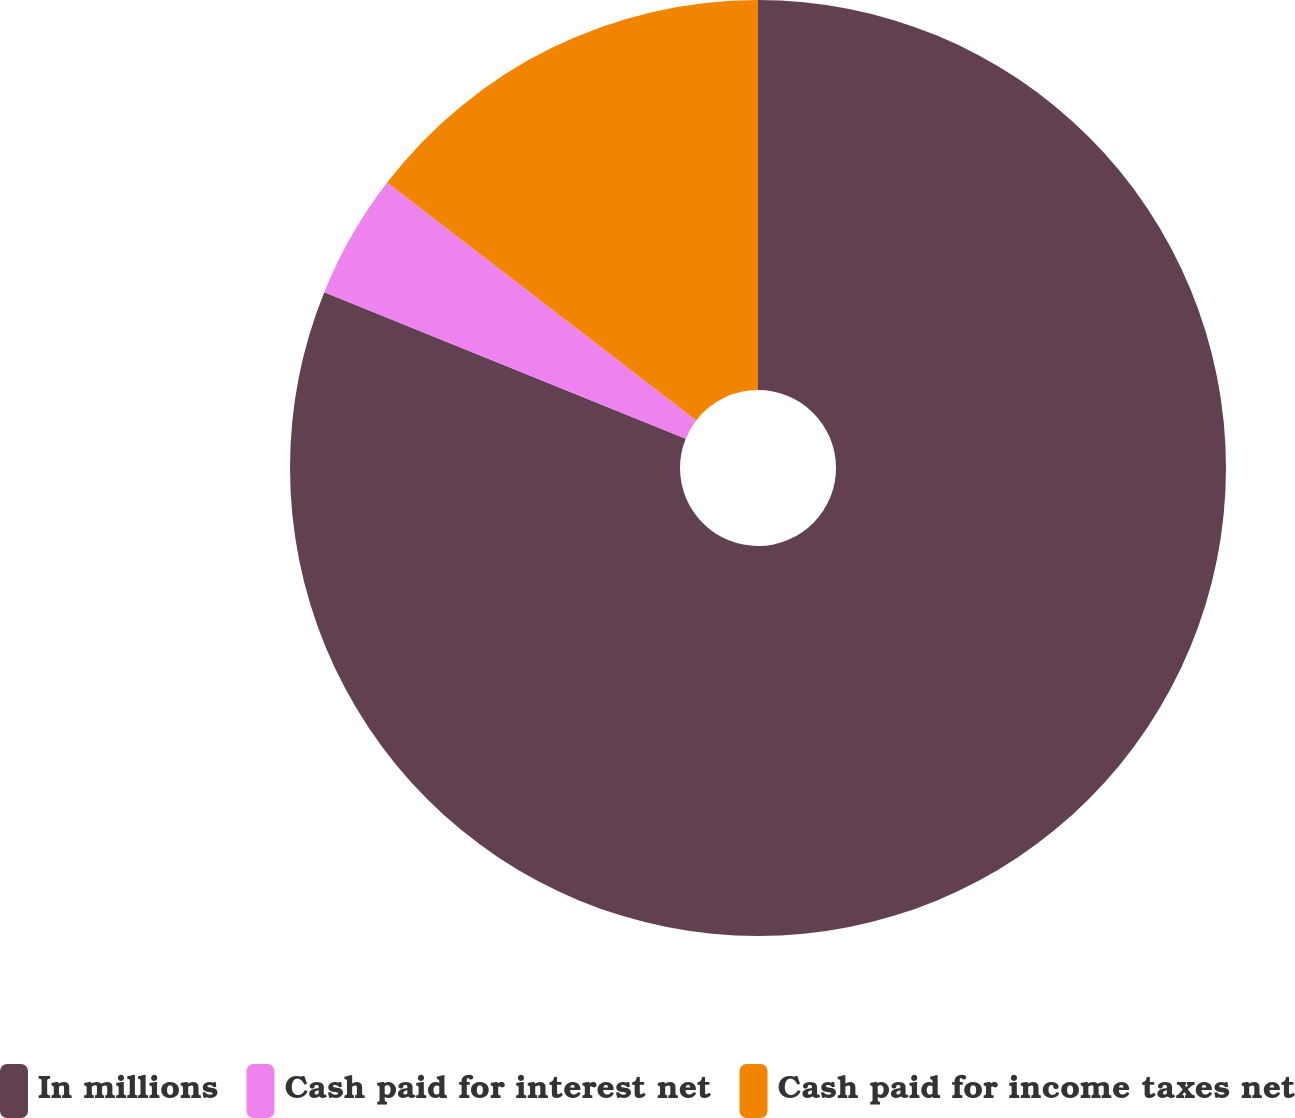<chart> <loc_0><loc_0><loc_500><loc_500><pie_chart><fcel>In millions<fcel>Cash paid for interest net<fcel>Cash paid for income taxes net<nl><fcel>81.12%<fcel>4.31%<fcel>14.56%<nl></chart> 